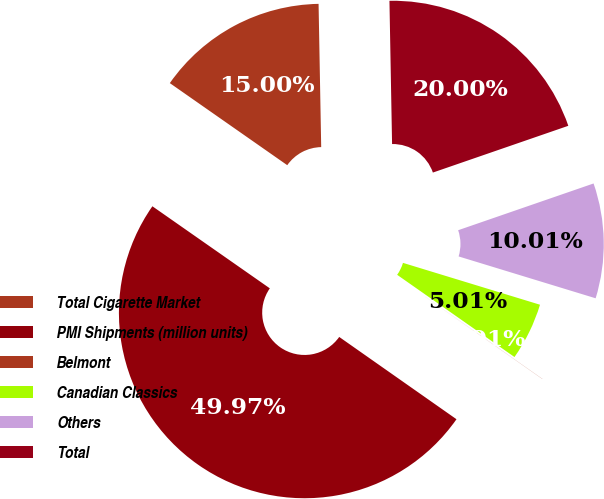Convert chart to OTSL. <chart><loc_0><loc_0><loc_500><loc_500><pie_chart><fcel>Total Cigarette Market<fcel>PMI Shipments (million units)<fcel>Belmont<fcel>Canadian Classics<fcel>Others<fcel>Total<nl><fcel>15.0%<fcel>49.97%<fcel>0.01%<fcel>5.01%<fcel>10.01%<fcel>20.0%<nl></chart> 